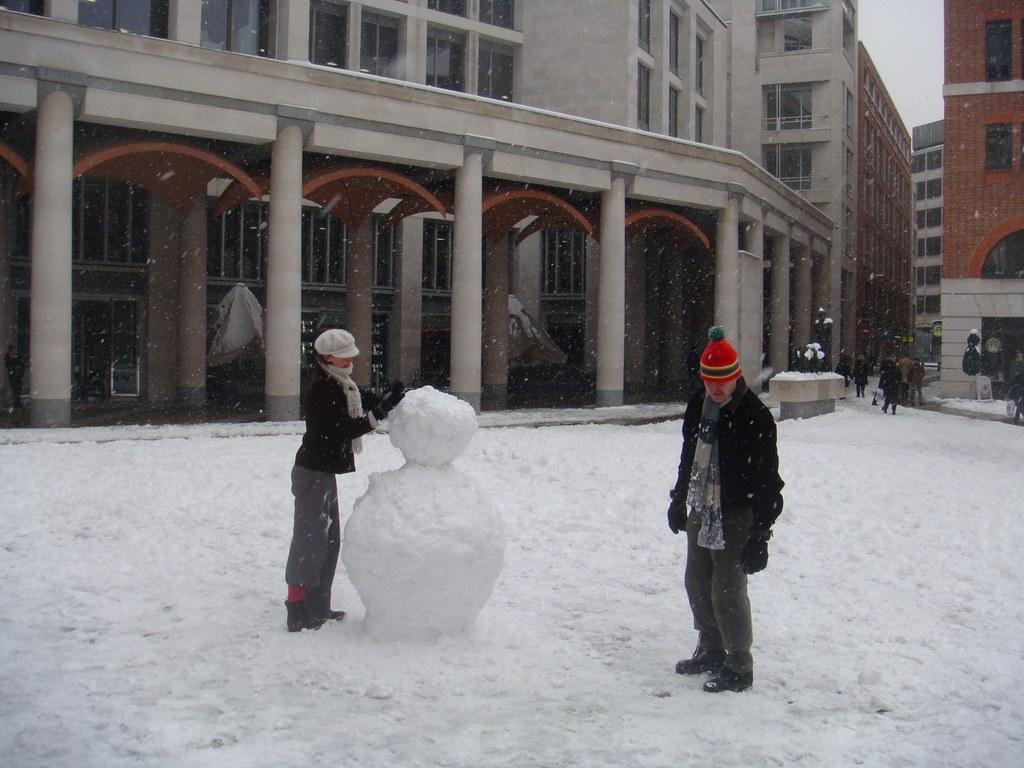Can you describe this image briefly? To the bottom of the image there is snow on the ground. To the left side of the image there is a person with black jacket, grey pant and cap on the head is making the snowman. And to the right side of the image there is a man with red cap, black jacket is standing on the snow. In the background there is a building with pillars, walls, windows and doors. And in the background to the right side there are few people walking and to the right top corner there is a building with brick wall and window. 